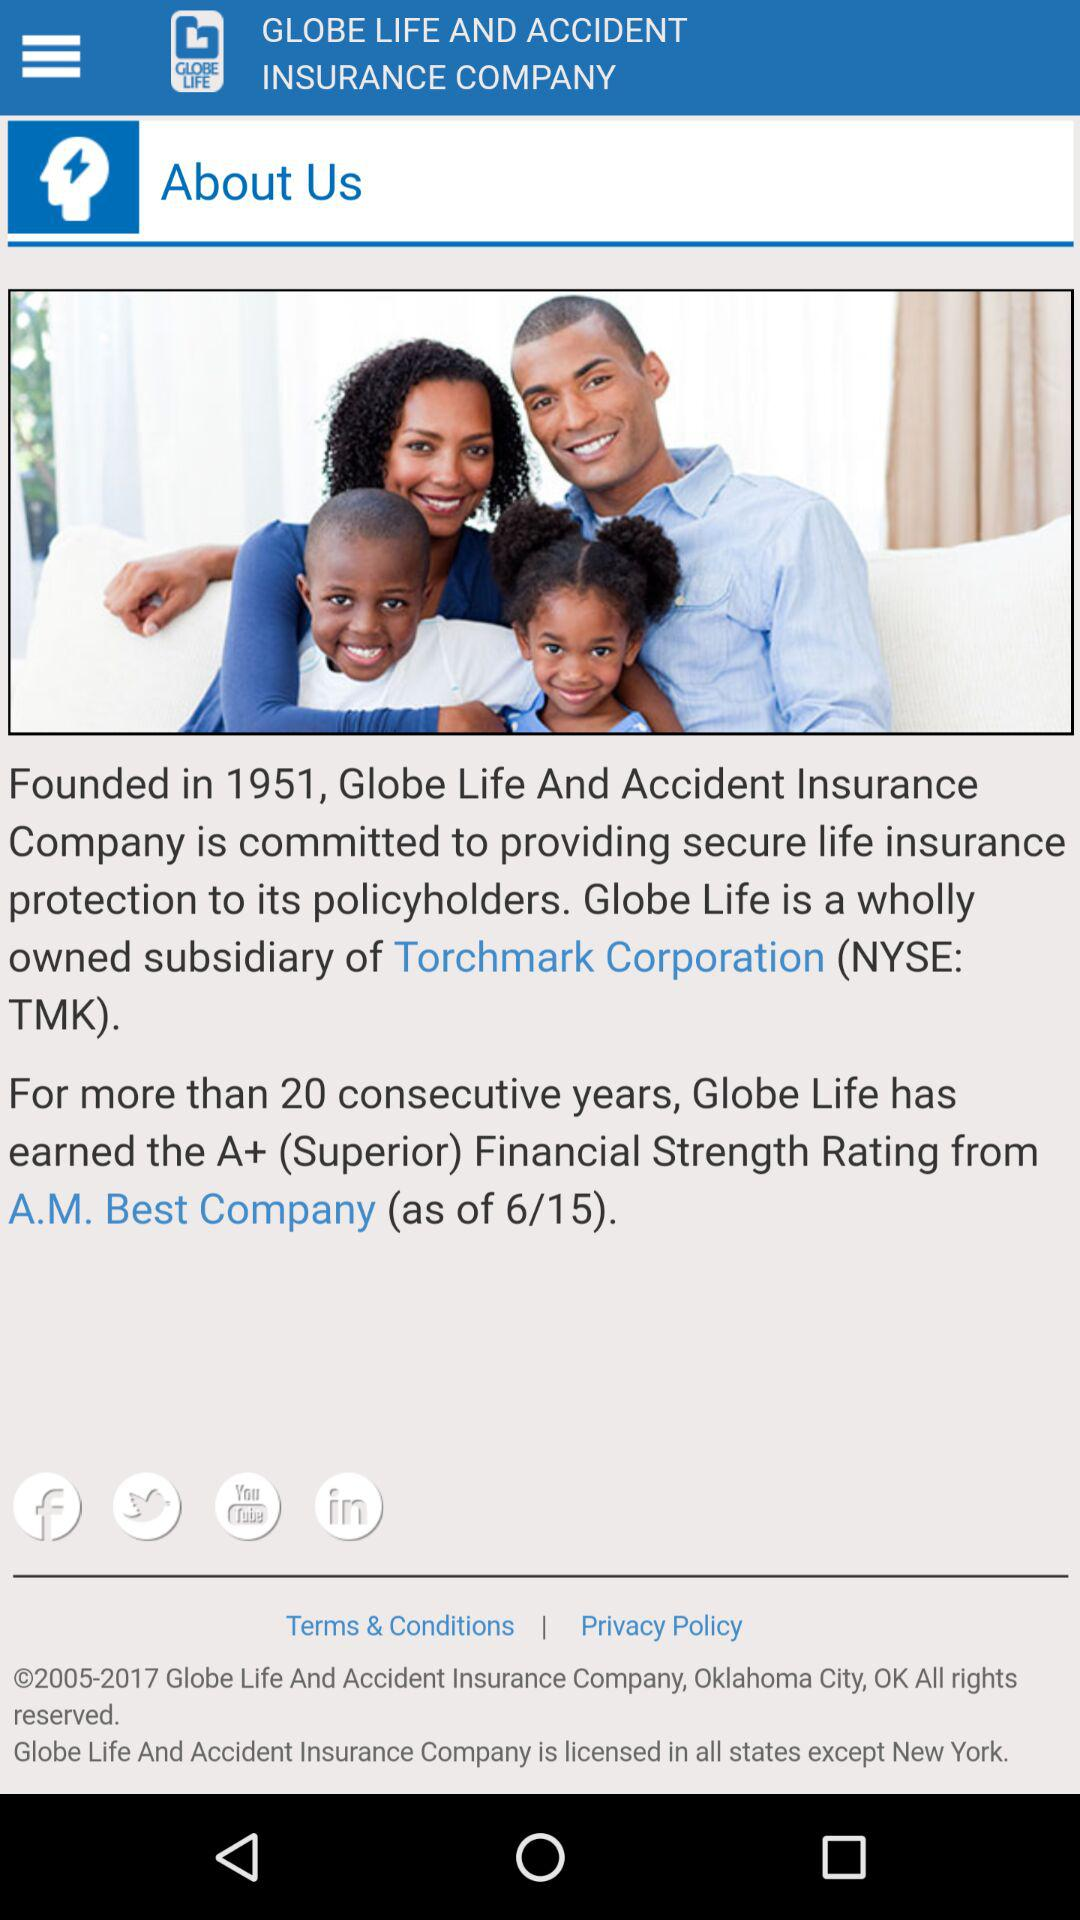In which year was the company "Global Life And Accident Insurance" founded? The company was founded in 1951. 